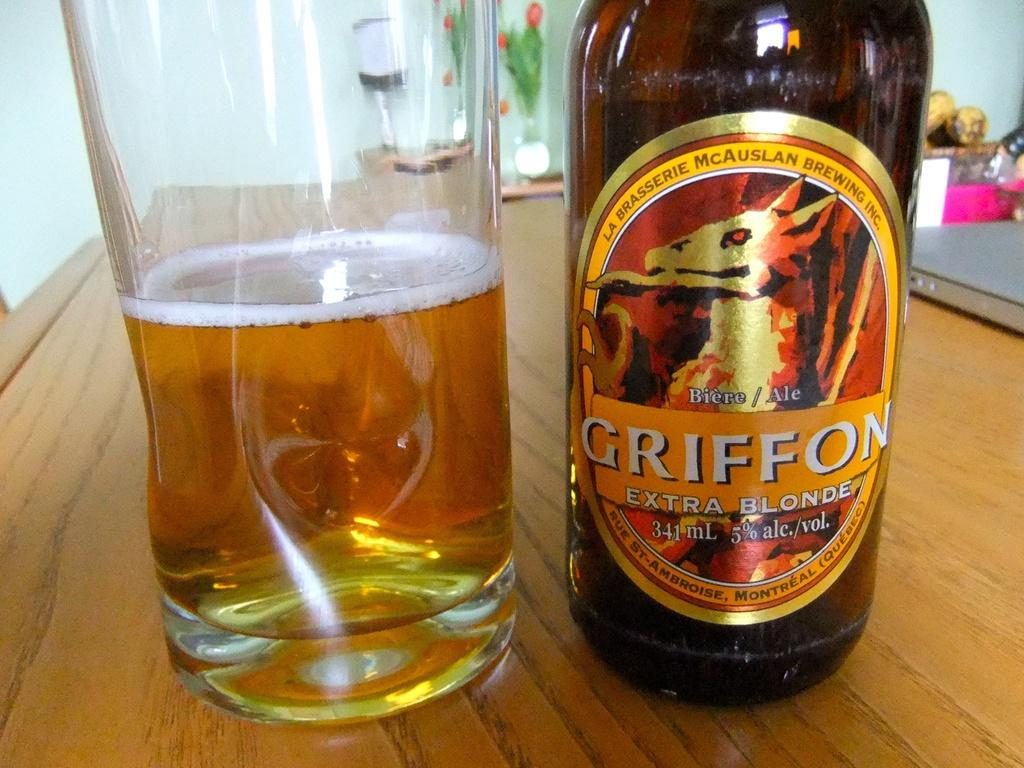What is in the glass and bottle that are visible in the image? The glass and bottle contain wine. What other objects can be seen in the image? There is a table at the bottom of the image, a wall in the background, and a flower vase in the middle of the image. How does the jelly travel on the boat in the image? There is no jelly or boat present in the image. Can you describe the running motion of the person in the image? There is no person running in the image; it only features a glass, bottle, table, wall, and flower vase. 